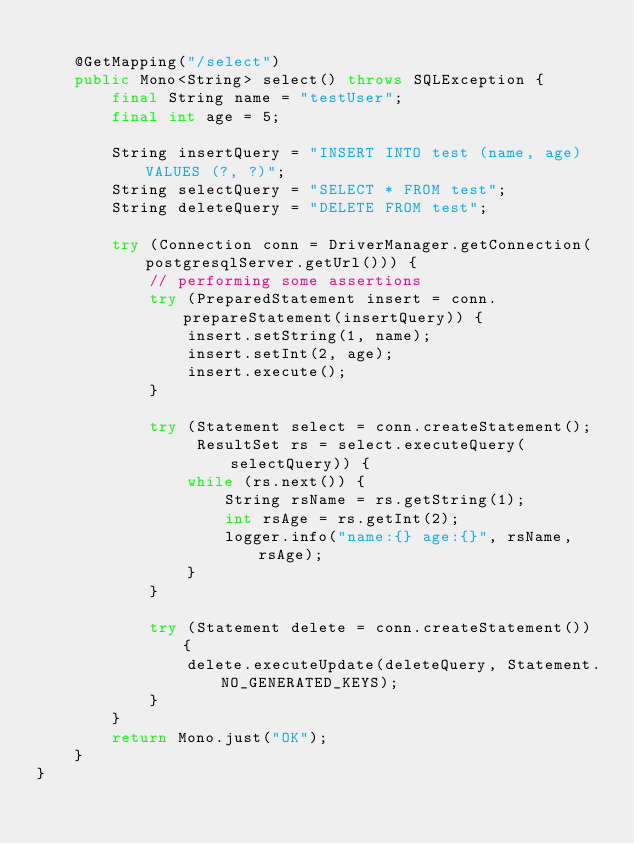<code> <loc_0><loc_0><loc_500><loc_500><_Java_>
    @GetMapping("/select")
    public Mono<String> select() throws SQLException {
        final String name = "testUser";
        final int age = 5;

        String insertQuery = "INSERT INTO test (name, age) VALUES (?, ?)";
        String selectQuery = "SELECT * FROM test";
        String deleteQuery = "DELETE FROM test";

        try (Connection conn = DriverManager.getConnection(postgresqlServer.getUrl())) {
            // performing some assertions
            try (PreparedStatement insert = conn.prepareStatement(insertQuery)) {
                insert.setString(1, name);
                insert.setInt(2, age);
                insert.execute();
            }

            try (Statement select = conn.createStatement();
                 ResultSet rs = select.executeQuery(selectQuery)) {
                while (rs.next()) {
                    String rsName = rs.getString(1);
                    int rsAge = rs.getInt(2);
                    logger.info("name:{} age:{}", rsName, rsAge);
                }
            }

            try (Statement delete = conn.createStatement()) {
                delete.executeUpdate(deleteQuery, Statement.NO_GENERATED_KEYS);
            }
        }
        return Mono.just("OK");
    }
}
</code> 